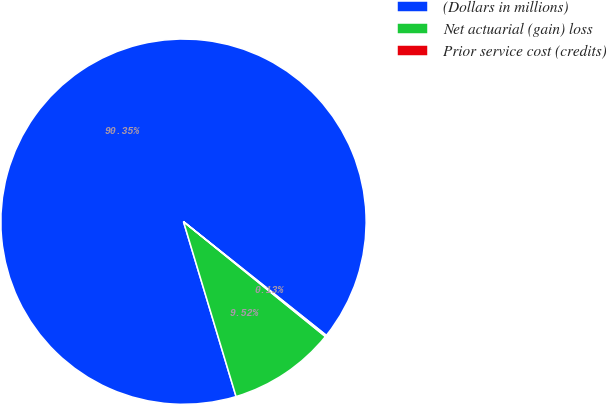Convert chart to OTSL. <chart><loc_0><loc_0><loc_500><loc_500><pie_chart><fcel>(Dollars in millions)<fcel>Net actuarial (gain) loss<fcel>Prior service cost (credits)<nl><fcel>90.34%<fcel>9.52%<fcel>0.13%<nl></chart> 